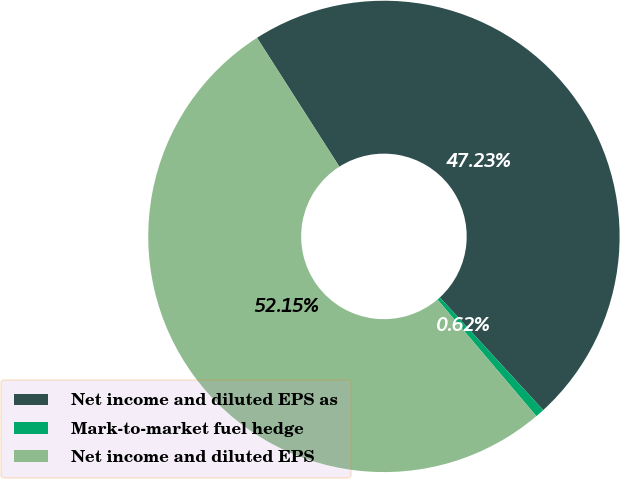Convert chart. <chart><loc_0><loc_0><loc_500><loc_500><pie_chart><fcel>Net income and diluted EPS as<fcel>Mark-to-market fuel hedge<fcel>Net income and diluted EPS<nl><fcel>47.23%<fcel>0.62%<fcel>52.14%<nl></chart> 